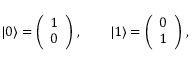Convert formula to latex. <formula><loc_0><loc_0><loc_500><loc_500>| 0 \rangle = \left ( \begin{array} { l } { 1 } \\ { 0 } \end{array} \right ) \, , \quad | 1 \rangle = \left ( \begin{array} { l } { 0 } \\ { 1 } \end{array} \right ) \, ,</formula> 